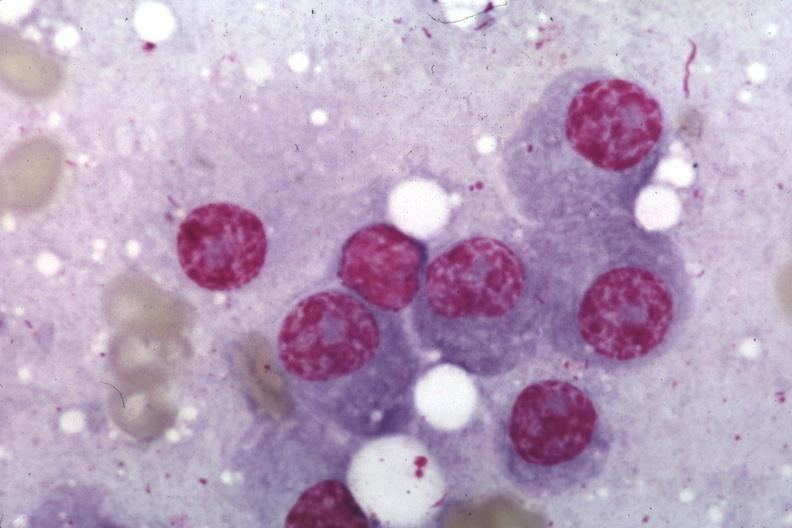s lymphangiomatosis present?
Answer the question using a single word or phrase. No 